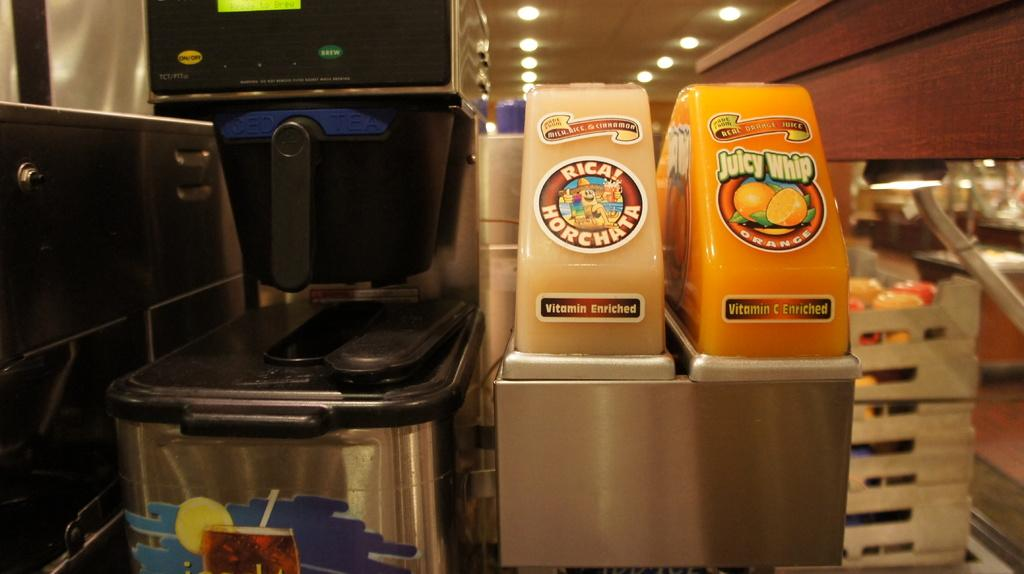<image>
Describe the image concisely. a drink machine that is labeled 'rica horchata' 